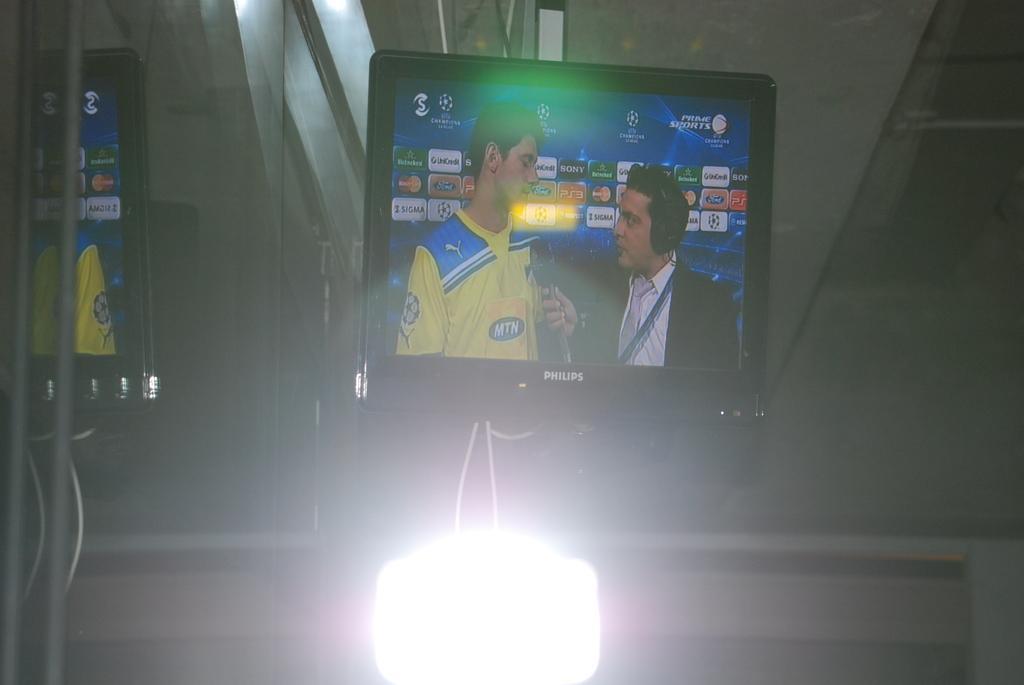<image>
Create a compact narrative representing the image presented. A Phillips TV showing an athlete getting interviewed. 